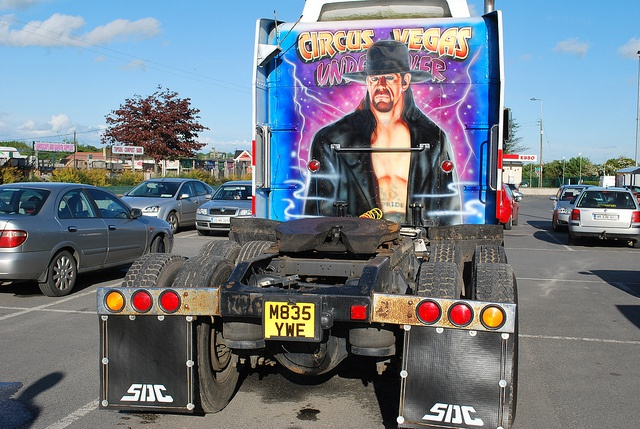Describe the objects in this image and their specific colors. I can see truck in lightblue, gray, black, white, and darkgray tones, people in lightblue, black, gray, tan, and ivory tones, car in lightblue, gray, black, blue, and navy tones, car in lightblue, black, lightgray, darkgray, and gray tones, and car in lightblue, gray, blue, and black tones in this image. 